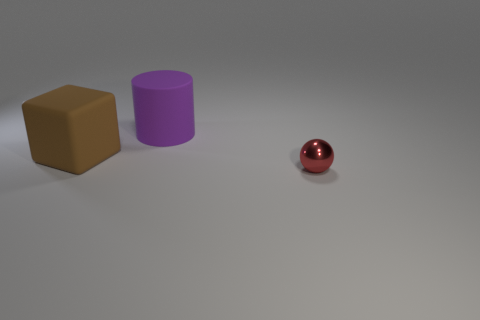Add 3 small brown metallic blocks. How many objects exist? 6 Subtract all spheres. How many objects are left? 2 Subtract all small blue blocks. Subtract all red metallic balls. How many objects are left? 2 Add 1 blocks. How many blocks are left? 2 Add 3 red matte blocks. How many red matte blocks exist? 3 Subtract 0 gray cubes. How many objects are left? 3 